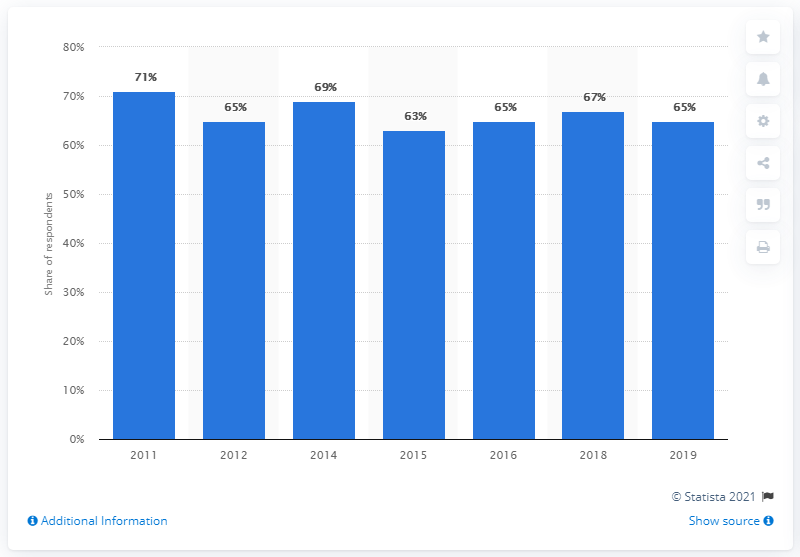Give some essential details in this illustration. The majority of survey respondents reported reading a printed book each year in 2011. 